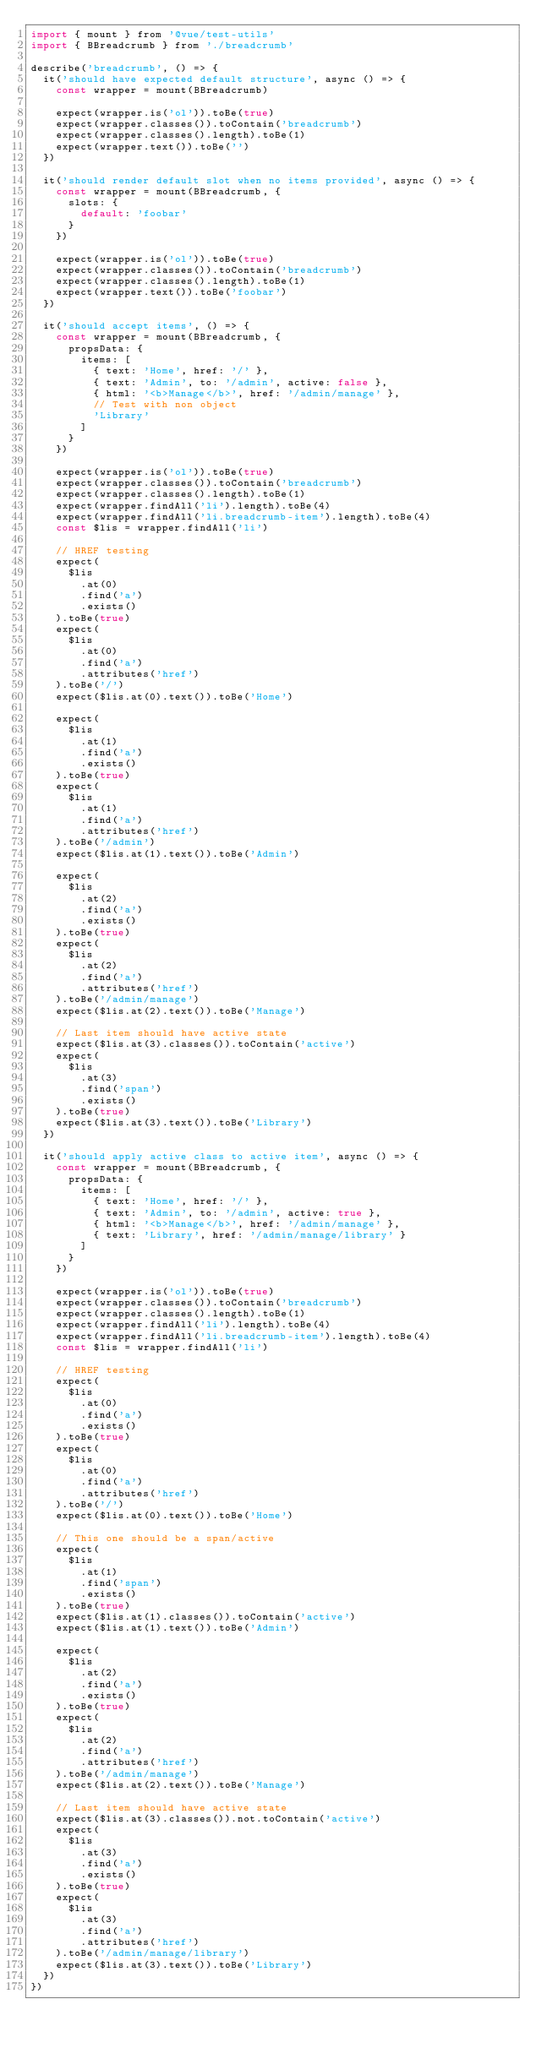Convert code to text. <code><loc_0><loc_0><loc_500><loc_500><_JavaScript_>import { mount } from '@vue/test-utils'
import { BBreadcrumb } from './breadcrumb'

describe('breadcrumb', () => {
  it('should have expected default structure', async () => {
    const wrapper = mount(BBreadcrumb)

    expect(wrapper.is('ol')).toBe(true)
    expect(wrapper.classes()).toContain('breadcrumb')
    expect(wrapper.classes().length).toBe(1)
    expect(wrapper.text()).toBe('')
  })

  it('should render default slot when no items provided', async () => {
    const wrapper = mount(BBreadcrumb, {
      slots: {
        default: 'foobar'
      }
    })

    expect(wrapper.is('ol')).toBe(true)
    expect(wrapper.classes()).toContain('breadcrumb')
    expect(wrapper.classes().length).toBe(1)
    expect(wrapper.text()).toBe('foobar')
  })

  it('should accept items', () => {
    const wrapper = mount(BBreadcrumb, {
      propsData: {
        items: [
          { text: 'Home', href: '/' },
          { text: 'Admin', to: '/admin', active: false },
          { html: '<b>Manage</b>', href: '/admin/manage' },
          // Test with non object
          'Library'
        ]
      }
    })

    expect(wrapper.is('ol')).toBe(true)
    expect(wrapper.classes()).toContain('breadcrumb')
    expect(wrapper.classes().length).toBe(1)
    expect(wrapper.findAll('li').length).toBe(4)
    expect(wrapper.findAll('li.breadcrumb-item').length).toBe(4)
    const $lis = wrapper.findAll('li')

    // HREF testing
    expect(
      $lis
        .at(0)
        .find('a')
        .exists()
    ).toBe(true)
    expect(
      $lis
        .at(0)
        .find('a')
        .attributes('href')
    ).toBe('/')
    expect($lis.at(0).text()).toBe('Home')

    expect(
      $lis
        .at(1)
        .find('a')
        .exists()
    ).toBe(true)
    expect(
      $lis
        .at(1)
        .find('a')
        .attributes('href')
    ).toBe('/admin')
    expect($lis.at(1).text()).toBe('Admin')

    expect(
      $lis
        .at(2)
        .find('a')
        .exists()
    ).toBe(true)
    expect(
      $lis
        .at(2)
        .find('a')
        .attributes('href')
    ).toBe('/admin/manage')
    expect($lis.at(2).text()).toBe('Manage')

    // Last item should have active state
    expect($lis.at(3).classes()).toContain('active')
    expect(
      $lis
        .at(3)
        .find('span')
        .exists()
    ).toBe(true)
    expect($lis.at(3).text()).toBe('Library')
  })

  it('should apply active class to active item', async () => {
    const wrapper = mount(BBreadcrumb, {
      propsData: {
        items: [
          { text: 'Home', href: '/' },
          { text: 'Admin', to: '/admin', active: true },
          { html: '<b>Manage</b>', href: '/admin/manage' },
          { text: 'Library', href: '/admin/manage/library' }
        ]
      }
    })

    expect(wrapper.is('ol')).toBe(true)
    expect(wrapper.classes()).toContain('breadcrumb')
    expect(wrapper.classes().length).toBe(1)
    expect(wrapper.findAll('li').length).toBe(4)
    expect(wrapper.findAll('li.breadcrumb-item').length).toBe(4)
    const $lis = wrapper.findAll('li')

    // HREF testing
    expect(
      $lis
        .at(0)
        .find('a')
        .exists()
    ).toBe(true)
    expect(
      $lis
        .at(0)
        .find('a')
        .attributes('href')
    ).toBe('/')
    expect($lis.at(0).text()).toBe('Home')

    // This one should be a span/active
    expect(
      $lis
        .at(1)
        .find('span')
        .exists()
    ).toBe(true)
    expect($lis.at(1).classes()).toContain('active')
    expect($lis.at(1).text()).toBe('Admin')

    expect(
      $lis
        .at(2)
        .find('a')
        .exists()
    ).toBe(true)
    expect(
      $lis
        .at(2)
        .find('a')
        .attributes('href')
    ).toBe('/admin/manage')
    expect($lis.at(2).text()).toBe('Manage')

    // Last item should have active state
    expect($lis.at(3).classes()).not.toContain('active')
    expect(
      $lis
        .at(3)
        .find('a')
        .exists()
    ).toBe(true)
    expect(
      $lis
        .at(3)
        .find('a')
        .attributes('href')
    ).toBe('/admin/manage/library')
    expect($lis.at(3).text()).toBe('Library')
  })
})
</code> 